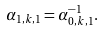<formula> <loc_0><loc_0><loc_500><loc_500>\alpha _ { 1 , k , 1 } = \alpha _ { 0 , k , 1 } ^ { - 1 } .</formula> 